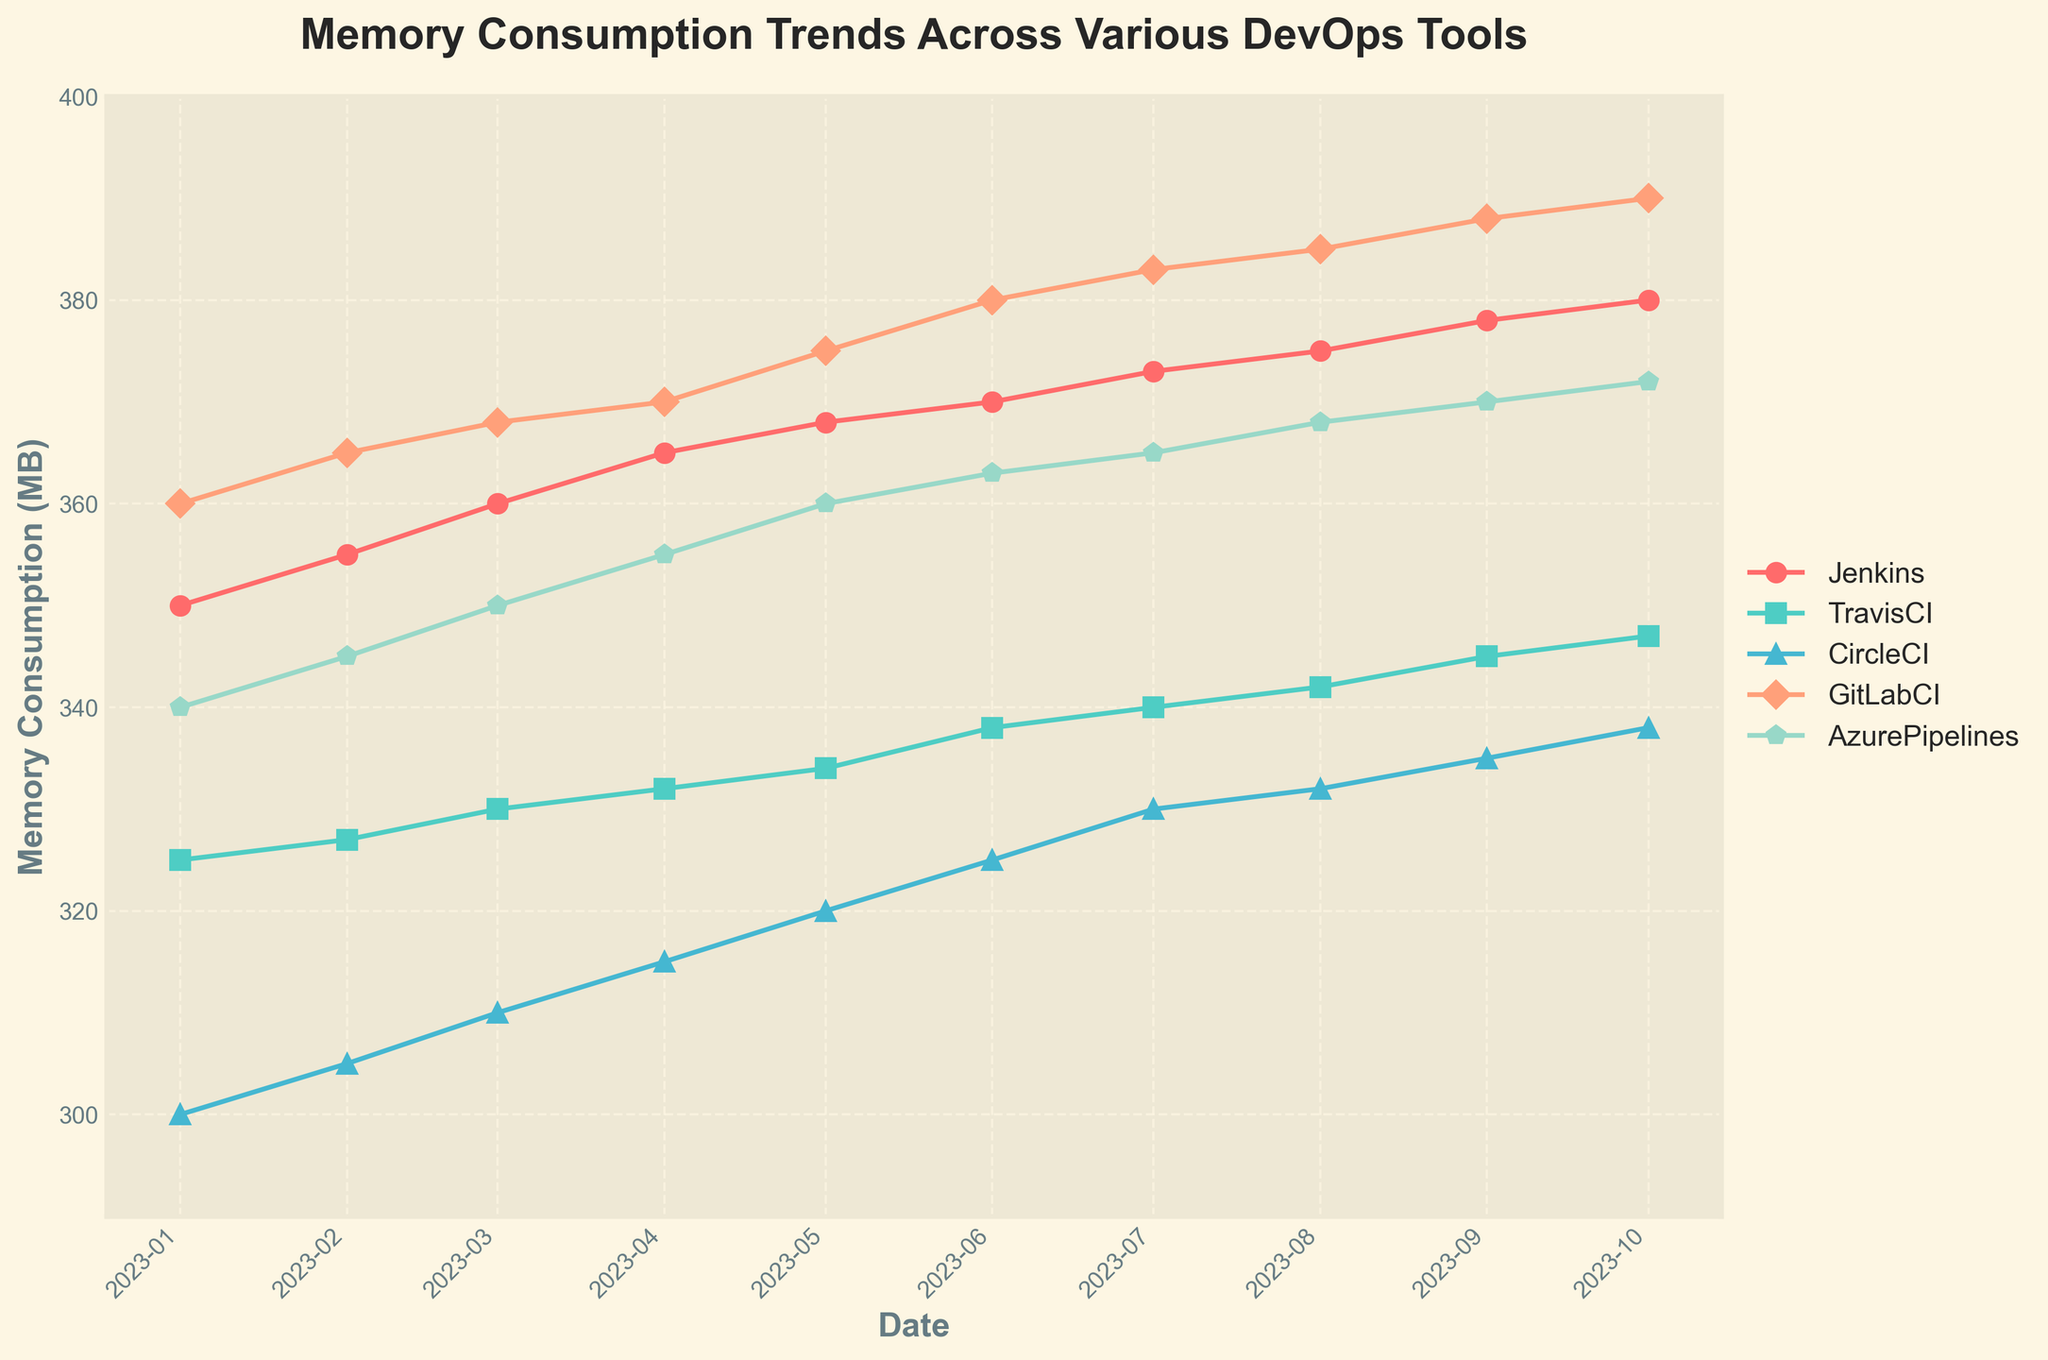What's the title of the plot? The title is prominently displayed at the top of the plot.
Answer: Memory Consumption Trends Across Various DevOps Tools What is the peak memory consumption for GitLabCI, and in which month does it occur? Look for the highest point on the GitLabCI line, which is indicated with the 'D' marker, and note the corresponding month.
Answer: 390 MB, October 2023 Which tool had the lowest starting memory consumption, and what was the value? Find the starting (leftmost) data point for each tool and identify the one with the lowest value. This is the value at January 2023 for each tool.
Answer: CircleCI, 300 MB How does the memory consumption trend of Azure Pipelines from January to October 2023? Trace the Azure Pipelines line (with the 'p' marker) from January to October 2023 and observe whether it generally increases, decreases, or fluctuates.
Answer: Increases By how much did the memory consumption of Jenkins increase from January to October 2023? Subtract the January value from the October value for Jenkins. January: 350 MB, October: 380 MB. Calculation: 380 - 350.
Answer: 30 MB Which two tools have the closest memory consumption values in August 2023, and what are those values? Check the values for each tool in August 2023 and find the two closest numbers.
Answer: Jenkins and Azure Pipelines, 375 MB and 368 MB What is the average memory consumption of CircleCI across the entire period? Sum all memory consumption values for CircleCI and divide by the number of data points. (300+305+310+315+320+325+330+332+335+338)/10.
Answer: 323 MB Between TravisCI and Jenkins, which tool shows a steeper increase in memory consumption over the period? Calculate the difference in memory consumption from January to October for both tools and compare. Jenkins: 380 - 350, TravisCI: 347 - 325.
Answer: Jenkins Given the trends observed, which tool would you estimate to have the highest memory consumption if we extended the data to December 2023? Extrapolate the trend lines based on current data for each tool to make an educated guess.
Answer: GitLabCI In which month do all tools, except Jenkins, show a noticeable increase in memory consumption? Compare the slopes of each line and identify the month where all but the Jenkins line show a noticeable rise.
Answer: June 2023 